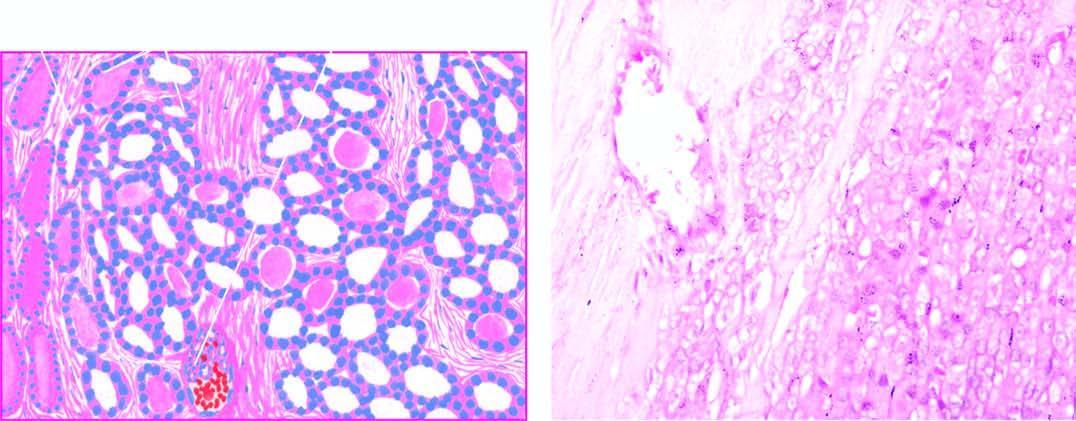re the follicles lined by tumour cells of various sizes?
Answer the question using a single word or phrase. Yes 